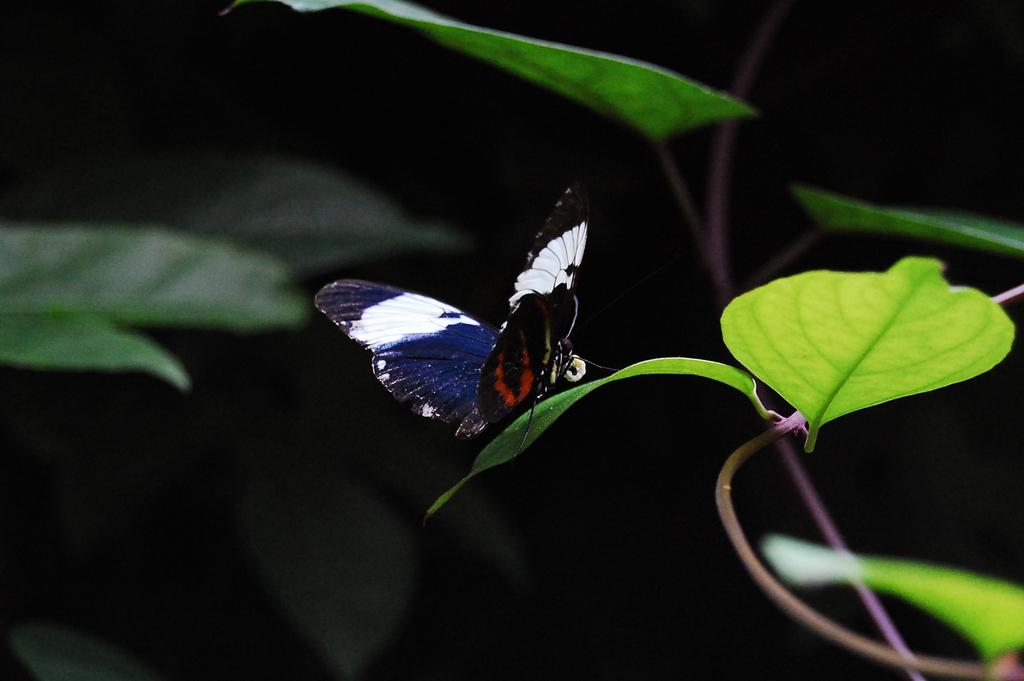What type of insect can be seen in the image? There is a butterfly in the image. What other natural elements are present in the image? There are leaves and stems in the image. Can you describe the background of the image? The background of the image is not clear. How many children are playing with the kitten in the image? There is no kitten or children present in the image; it features a butterfly and natural elements. 